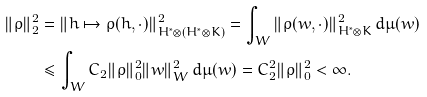<formula> <loc_0><loc_0><loc_500><loc_500>\| \rho \| _ { 2 } ^ { 2 } & = \| h \mapsto \rho ( h , \cdot ) \| _ { H ^ { * } \otimes ( H ^ { * } \otimes K ) } ^ { 2 } = \int _ { W } \| \rho ( w , \cdot ) \| _ { H ^ { * } \otimes K } ^ { 2 } \, d \mu ( w ) \\ & \leq \int _ { W } C _ { 2 } \| \rho \| _ { 0 } ^ { 2 } \| w \| _ { W } ^ { 2 } \, d \mu ( w ) = C _ { 2 } ^ { 2 } \| \rho \| _ { 0 } ^ { 2 } < \infty .</formula> 